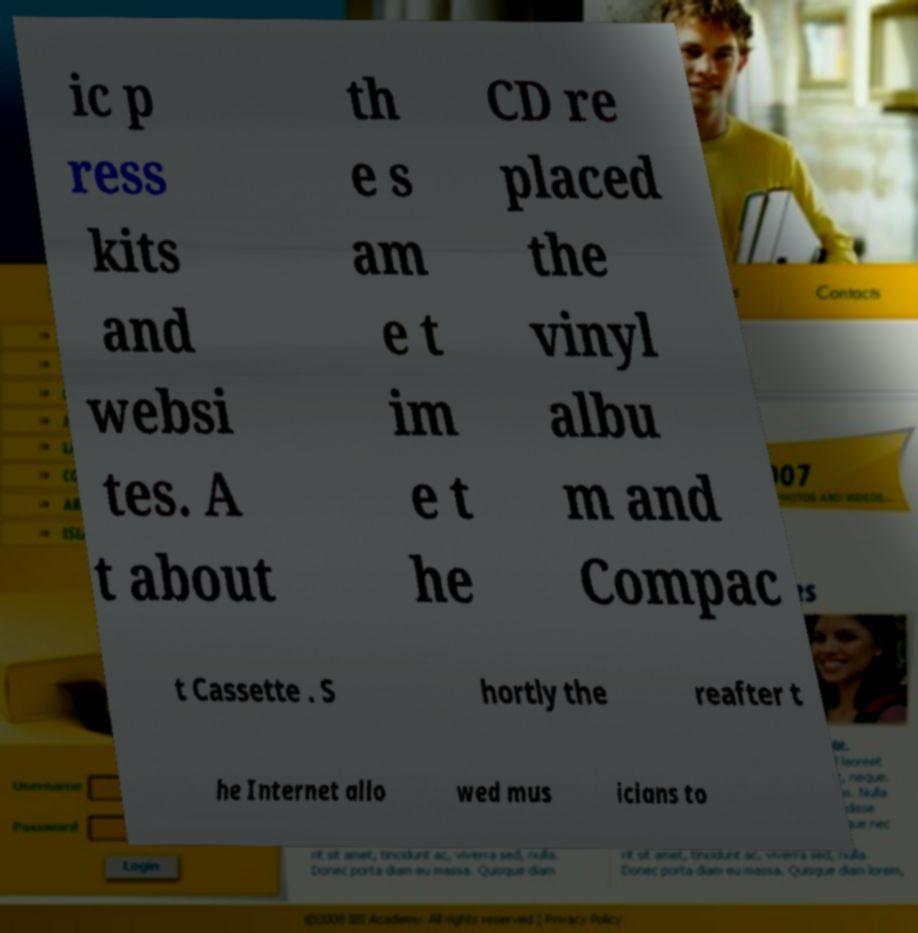Can you accurately transcribe the text from the provided image for me? ic p ress kits and websi tes. A t about th e s am e t im e t he CD re placed the vinyl albu m and Compac t Cassette . S hortly the reafter t he Internet allo wed mus icians to 